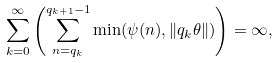<formula> <loc_0><loc_0><loc_500><loc_500>\sum _ { k = 0 } ^ { \infty } \left ( \sum _ { n = q _ { k } } ^ { q _ { k + 1 } - 1 } \min ( \psi ( n ) , \| q _ { k } \theta \| ) \right ) = \infty ,</formula> 